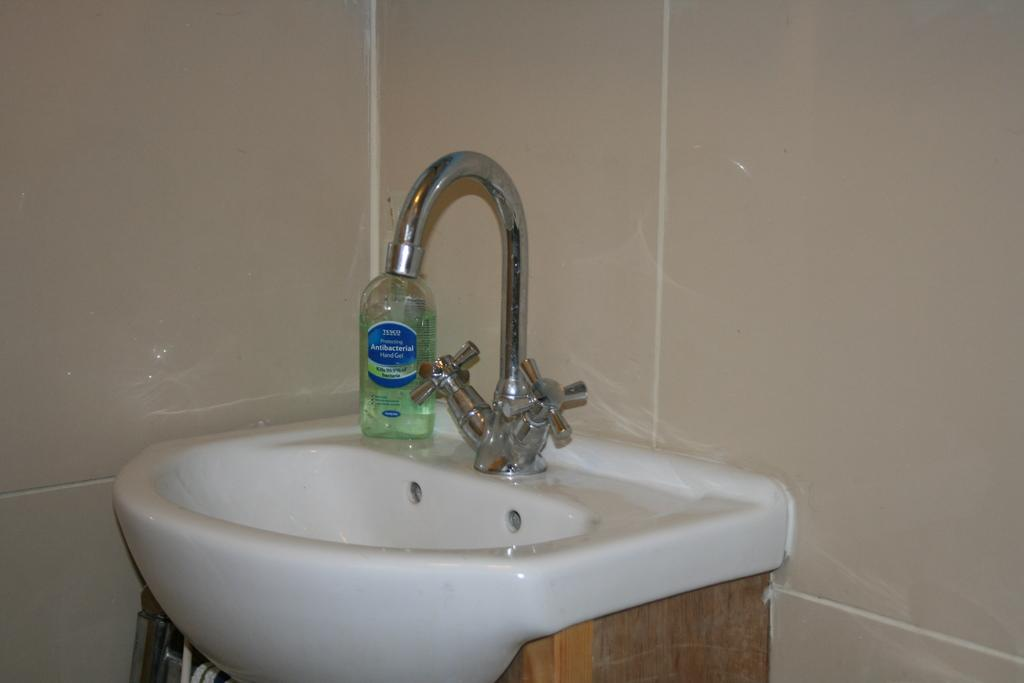What is located in the middle of the image? There is a tap, a sink, and a bottle in the middle of the image. What can be found at the top of the image? There is a well at the top of the image. What is present at the bottom of the image? There are objects at the bottom of the image. What type of bean is being used to sweeten the honey in the image? There is no bean or honey present in the image. What kind of picture is hanging on the wall in the image? There is no picture or wall present in the image. 